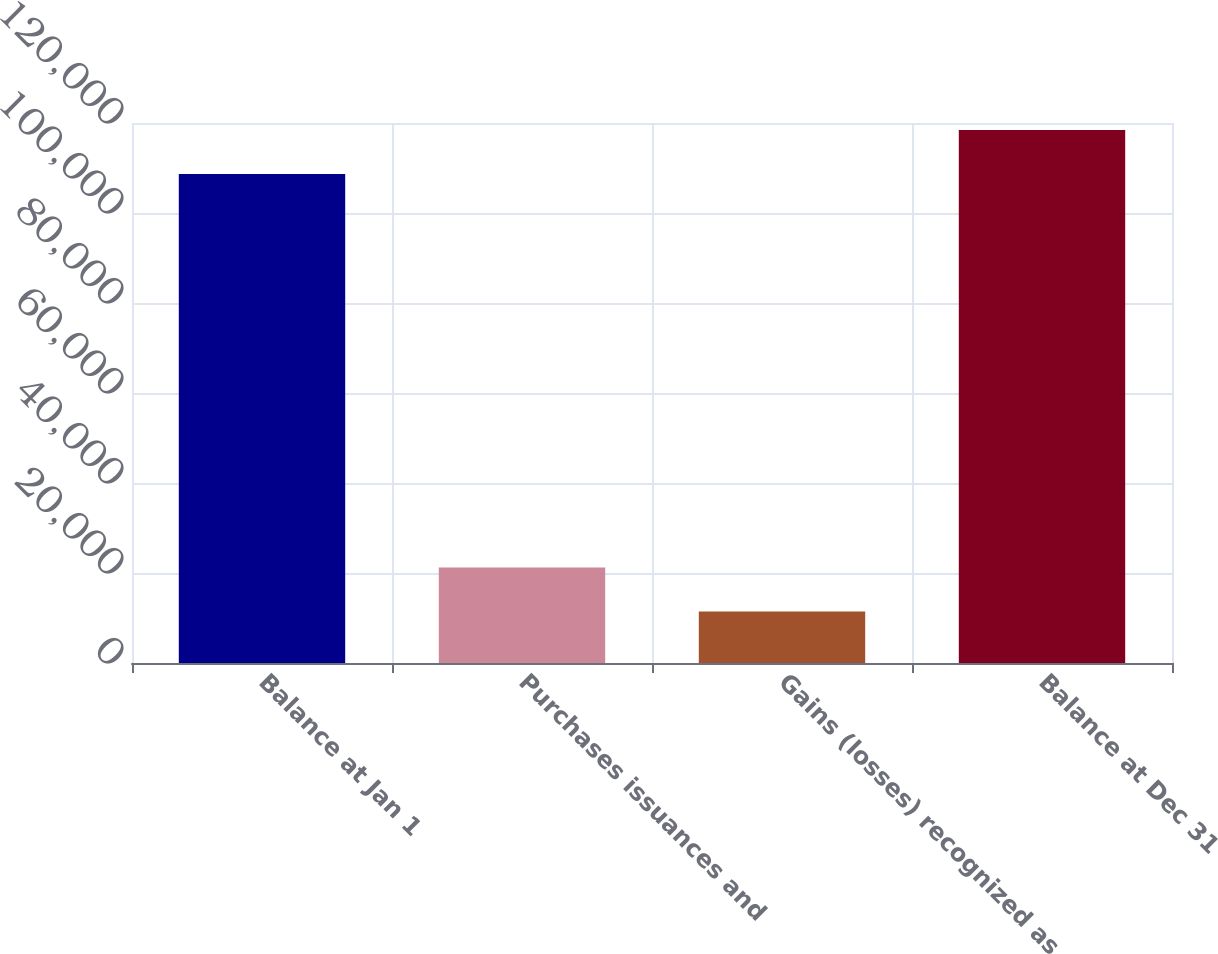Convert chart. <chart><loc_0><loc_0><loc_500><loc_500><bar_chart><fcel>Balance at Jan 1<fcel>Purchases issuances and<fcel>Gains (losses) recognized as<fcel>Balance at Dec 31<nl><fcel>108656<fcel>21230.2<fcel>11431<fcel>118455<nl></chart> 